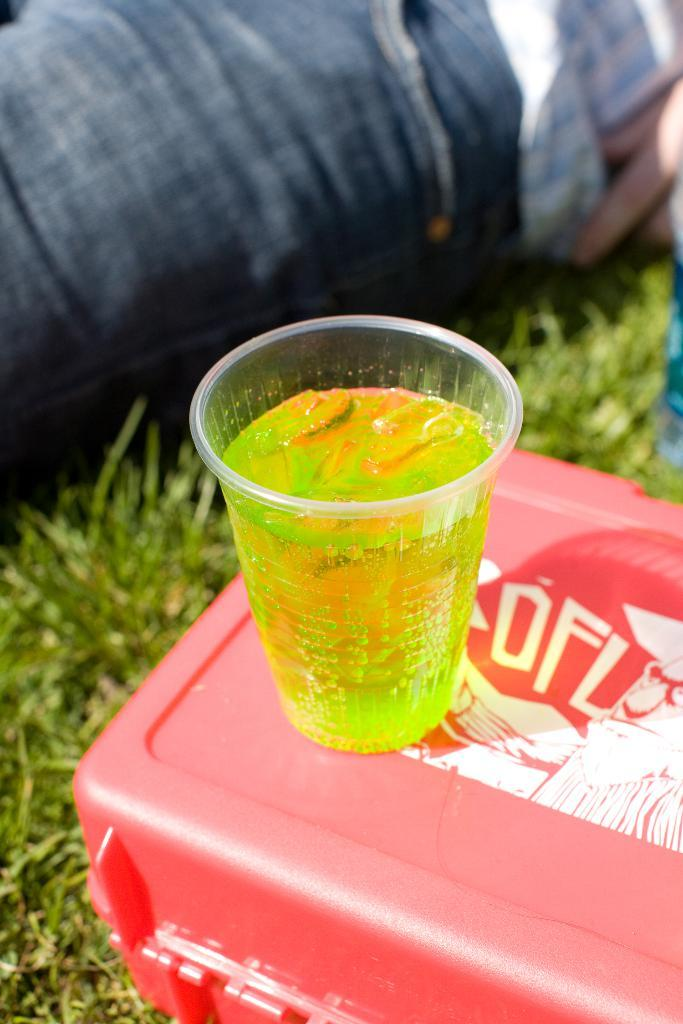What is inside the glass that is visible in the image? There is a drink inside the glass in the image. Where is the glass placed in the image? The glass is placed on a box in the image. What type of vegetation can be seen at the bottom of the image? There is grass at the bottom of the image. Can you describe any human presence in the image? There is a person's leg visible in the background of the image. What color are the eyes of the laborer in the image? There is no laborer present in the image, and therefore no eyes to describe. 